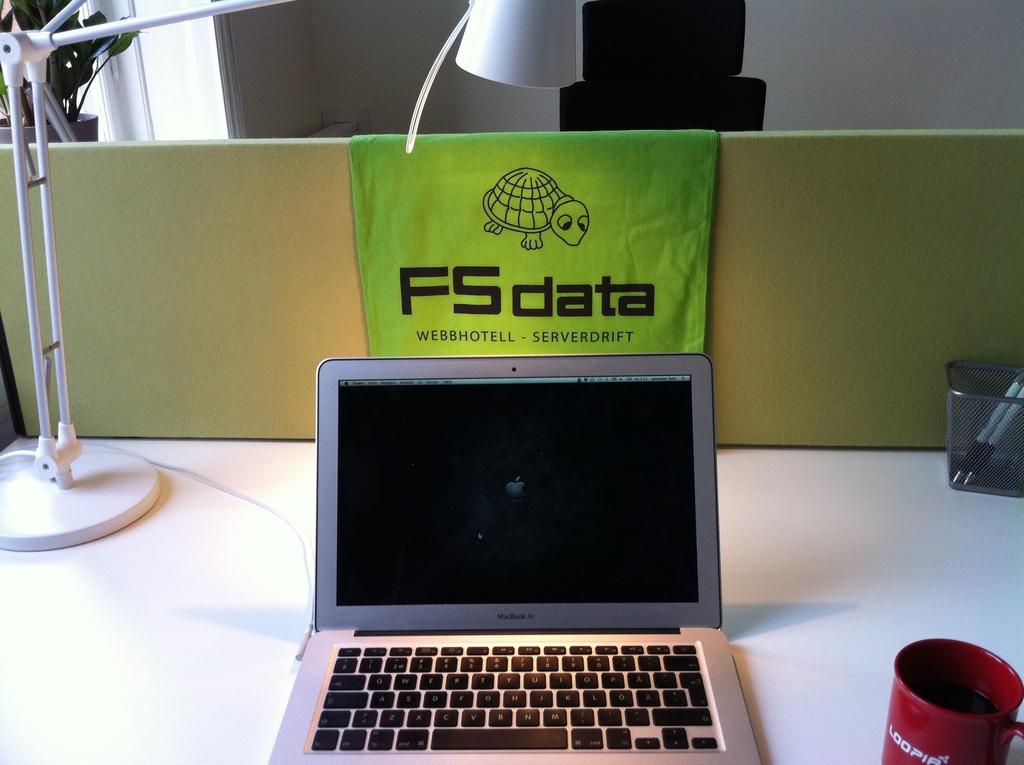What does the green cloth say in big letters?
Ensure brevity in your answer.  Fs data. 